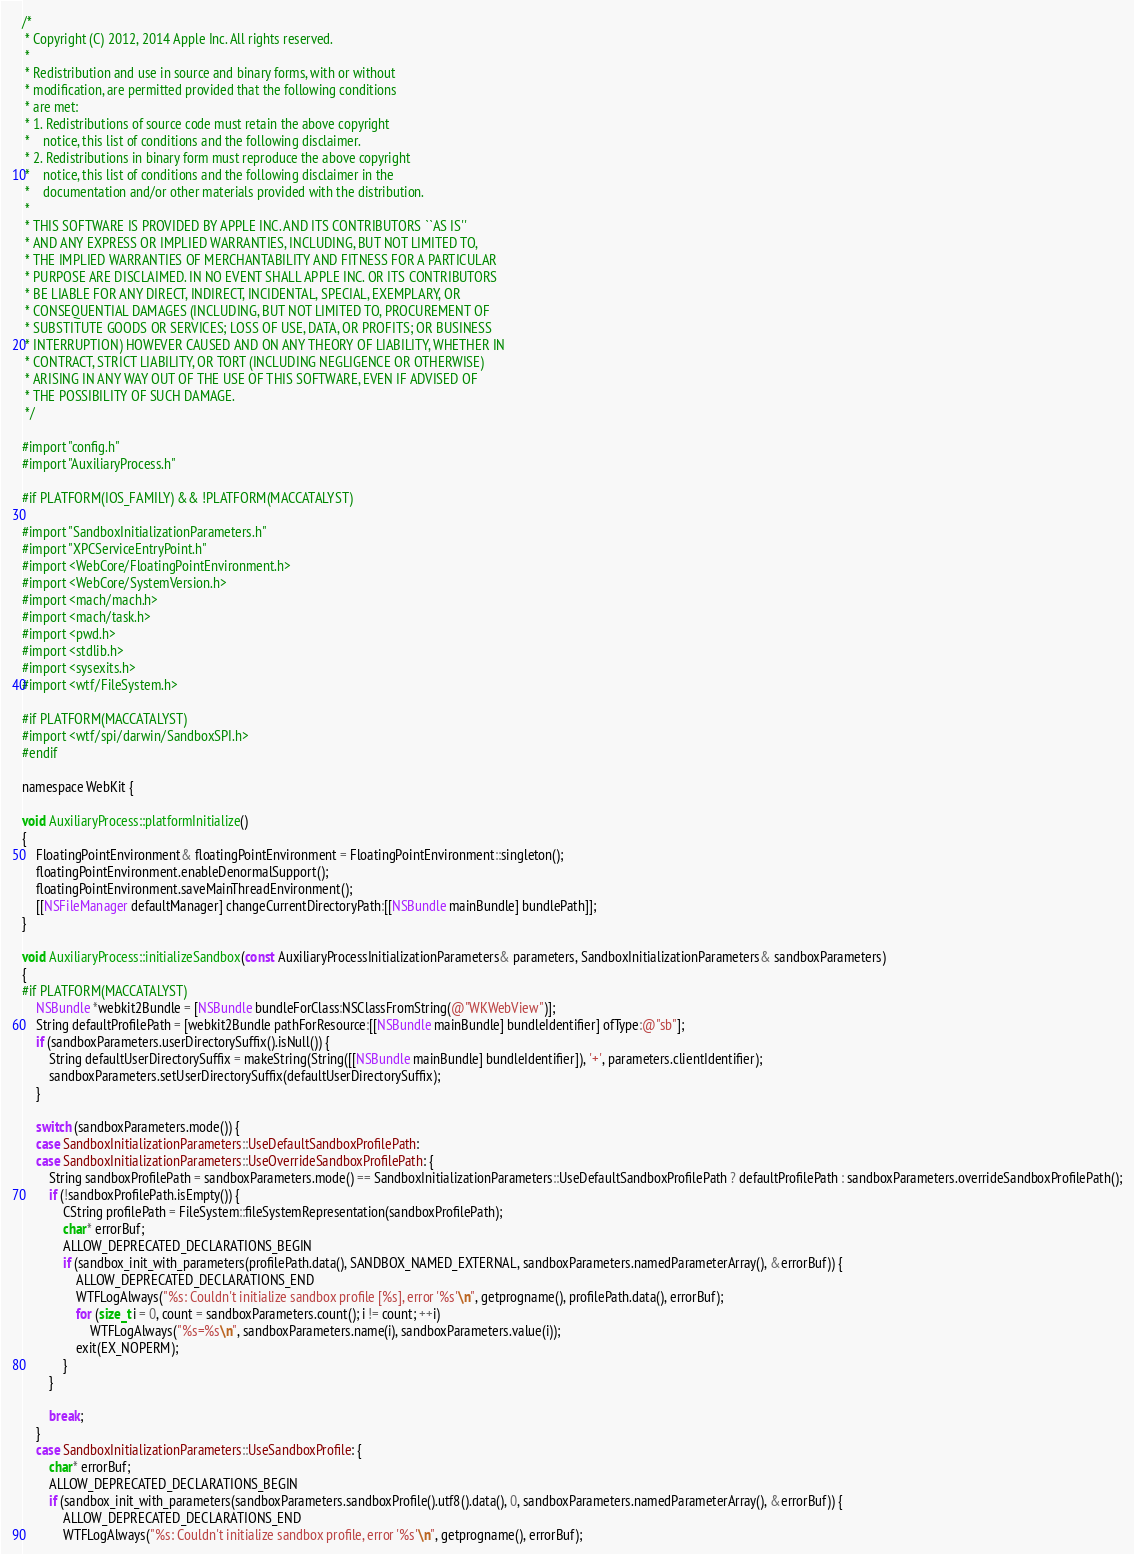Convert code to text. <code><loc_0><loc_0><loc_500><loc_500><_ObjectiveC_>/*
 * Copyright (C) 2012, 2014 Apple Inc. All rights reserved.
 *
 * Redistribution and use in source and binary forms, with or without
 * modification, are permitted provided that the following conditions
 * are met:
 * 1. Redistributions of source code must retain the above copyright
 *    notice, this list of conditions and the following disclaimer.
 * 2. Redistributions in binary form must reproduce the above copyright
 *    notice, this list of conditions and the following disclaimer in the
 *    documentation and/or other materials provided with the distribution.
 *
 * THIS SOFTWARE IS PROVIDED BY APPLE INC. AND ITS CONTRIBUTORS ``AS IS''
 * AND ANY EXPRESS OR IMPLIED WARRANTIES, INCLUDING, BUT NOT LIMITED TO,
 * THE IMPLIED WARRANTIES OF MERCHANTABILITY AND FITNESS FOR A PARTICULAR
 * PURPOSE ARE DISCLAIMED. IN NO EVENT SHALL APPLE INC. OR ITS CONTRIBUTORS
 * BE LIABLE FOR ANY DIRECT, INDIRECT, INCIDENTAL, SPECIAL, EXEMPLARY, OR
 * CONSEQUENTIAL DAMAGES (INCLUDING, BUT NOT LIMITED TO, PROCUREMENT OF
 * SUBSTITUTE GOODS OR SERVICES; LOSS OF USE, DATA, OR PROFITS; OR BUSINESS
 * INTERRUPTION) HOWEVER CAUSED AND ON ANY THEORY OF LIABILITY, WHETHER IN
 * CONTRACT, STRICT LIABILITY, OR TORT (INCLUDING NEGLIGENCE OR OTHERWISE)
 * ARISING IN ANY WAY OUT OF THE USE OF THIS SOFTWARE, EVEN IF ADVISED OF
 * THE POSSIBILITY OF SUCH DAMAGE.
 */

#import "config.h"
#import "AuxiliaryProcess.h"

#if PLATFORM(IOS_FAMILY) && !PLATFORM(MACCATALYST)

#import "SandboxInitializationParameters.h"
#import "XPCServiceEntryPoint.h"
#import <WebCore/FloatingPointEnvironment.h>
#import <WebCore/SystemVersion.h>
#import <mach/mach.h>
#import <mach/task.h>
#import <pwd.h>
#import <stdlib.h>
#import <sysexits.h>
#import <wtf/FileSystem.h>

#if PLATFORM(MACCATALYST)
#import <wtf/spi/darwin/SandboxSPI.h>
#endif

namespace WebKit {

void AuxiliaryProcess::platformInitialize()
{
    FloatingPointEnvironment& floatingPointEnvironment = FloatingPointEnvironment::singleton(); 
    floatingPointEnvironment.enableDenormalSupport(); 
    floatingPointEnvironment.saveMainThreadEnvironment(); 
    [[NSFileManager defaultManager] changeCurrentDirectoryPath:[[NSBundle mainBundle] bundlePath]];
}

void AuxiliaryProcess::initializeSandbox(const AuxiliaryProcessInitializationParameters& parameters, SandboxInitializationParameters& sandboxParameters)
{
#if PLATFORM(MACCATALYST)
    NSBundle *webkit2Bundle = [NSBundle bundleForClass:NSClassFromString(@"WKWebView")];
    String defaultProfilePath = [webkit2Bundle pathForResource:[[NSBundle mainBundle] bundleIdentifier] ofType:@"sb"];
    if (sandboxParameters.userDirectorySuffix().isNull()) {
        String defaultUserDirectorySuffix = makeString(String([[NSBundle mainBundle] bundleIdentifier]), '+', parameters.clientIdentifier);
        sandboxParameters.setUserDirectorySuffix(defaultUserDirectorySuffix);
    }

    switch (sandboxParameters.mode()) {
    case SandboxInitializationParameters::UseDefaultSandboxProfilePath:
    case SandboxInitializationParameters::UseOverrideSandboxProfilePath: {
        String sandboxProfilePath = sandboxParameters.mode() == SandboxInitializationParameters::UseDefaultSandboxProfilePath ? defaultProfilePath : sandboxParameters.overrideSandboxProfilePath();
        if (!sandboxProfilePath.isEmpty()) {
            CString profilePath = FileSystem::fileSystemRepresentation(sandboxProfilePath);
            char* errorBuf;
            ALLOW_DEPRECATED_DECLARATIONS_BEGIN
            if (sandbox_init_with_parameters(profilePath.data(), SANDBOX_NAMED_EXTERNAL, sandboxParameters.namedParameterArray(), &errorBuf)) {
                ALLOW_DEPRECATED_DECLARATIONS_END
                WTFLogAlways("%s: Couldn't initialize sandbox profile [%s], error '%s'\n", getprogname(), profilePath.data(), errorBuf);
                for (size_t i = 0, count = sandboxParameters.count(); i != count; ++i)
                    WTFLogAlways("%s=%s\n", sandboxParameters.name(i), sandboxParameters.value(i));
                exit(EX_NOPERM);
            }
        }

        break;
    }
    case SandboxInitializationParameters::UseSandboxProfile: {
        char* errorBuf;
        ALLOW_DEPRECATED_DECLARATIONS_BEGIN
        if (sandbox_init_with_parameters(sandboxParameters.sandboxProfile().utf8().data(), 0, sandboxParameters.namedParameterArray(), &errorBuf)) {
            ALLOW_DEPRECATED_DECLARATIONS_END
            WTFLogAlways("%s: Couldn't initialize sandbox profile, error '%s'\n", getprogname(), errorBuf);</code> 